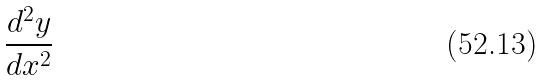Convert formula to latex. <formula><loc_0><loc_0><loc_500><loc_500>\frac { d ^ { 2 } y } { d x ^ { 2 } }</formula> 